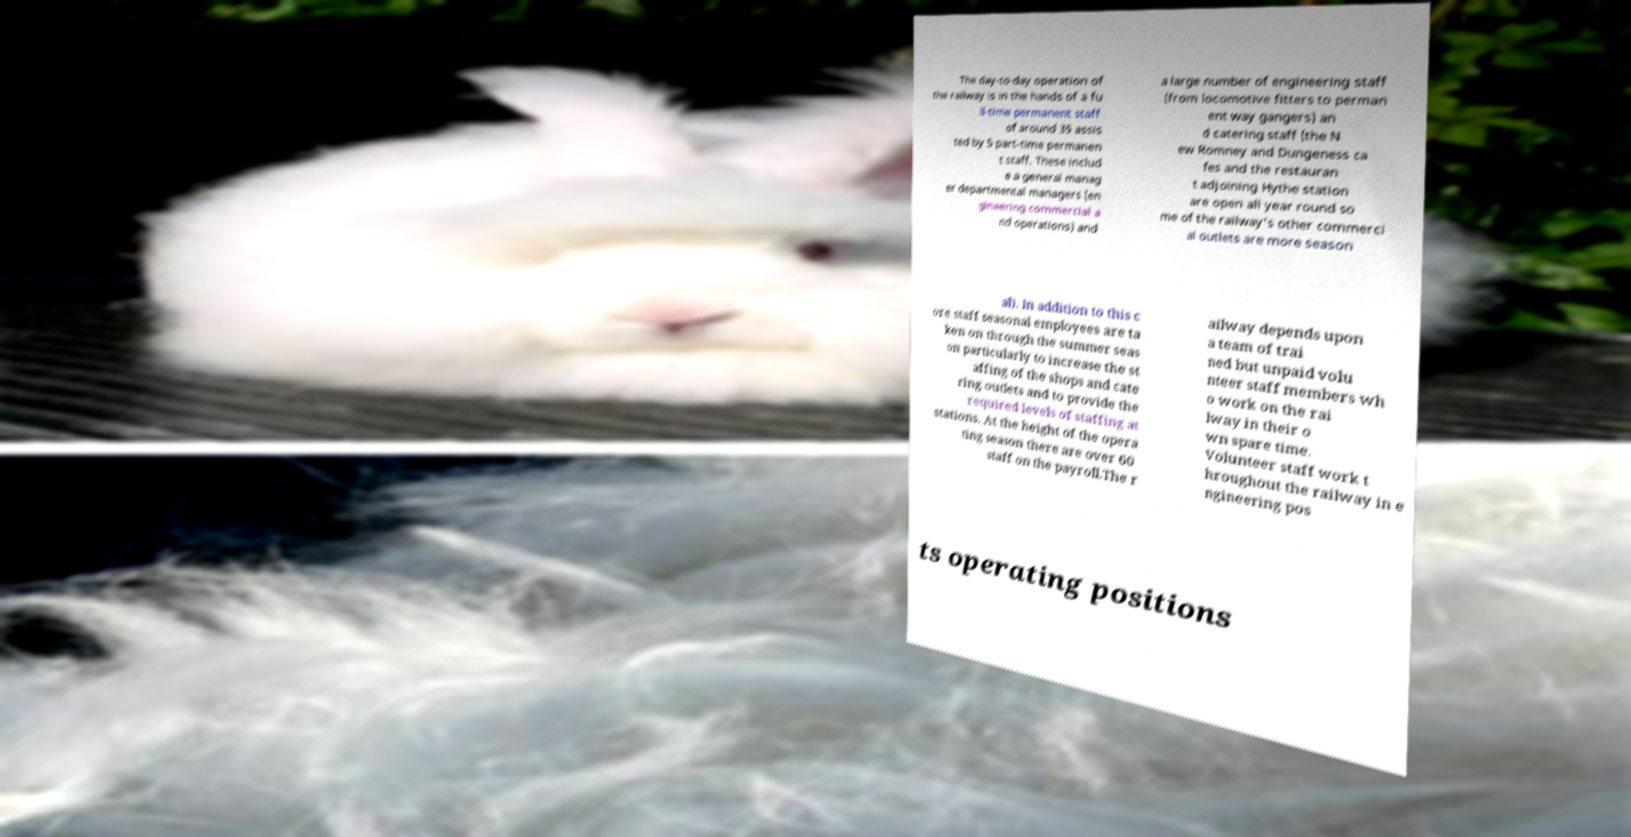Could you assist in decoding the text presented in this image and type it out clearly? The day-to-day operation of the railway is in the hands of a fu ll-time permanent staff of around 35 assis ted by 5 part-time permanen t staff. These includ e a general manag er departmental managers (en gineering commercial a nd operations) and a large number of engineering staff (from locomotive fitters to perman ent way gangers) an d catering staff (the N ew Romney and Dungeness ca fes and the restauran t adjoining Hythe station are open all year round so me of the railway's other commerci al outlets are more season al). In addition to this c ore staff seasonal employees are ta ken on through the summer seas on particularly to increase the st affing of the shops and cate ring outlets and to provide the required levels of staffing at stations. At the height of the opera ting season there are over 60 staff on the payroll.The r ailway depends upon a team of trai ned but unpaid volu nteer staff members wh o work on the rai lway in their o wn spare time. Volunteer staff work t hroughout the railway in e ngineering pos ts operating positions 